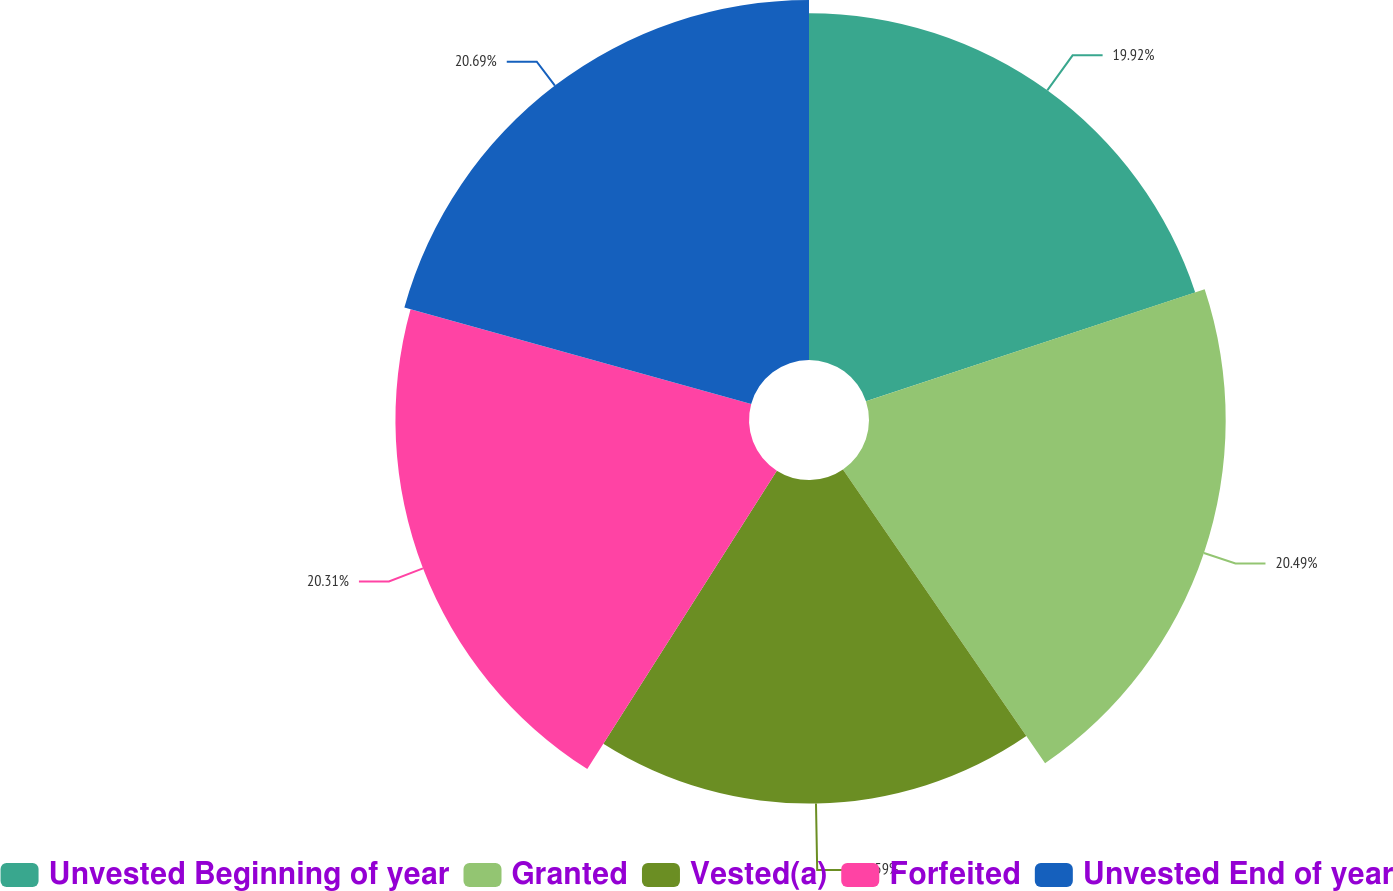<chart> <loc_0><loc_0><loc_500><loc_500><pie_chart><fcel>Unvested Beginning of year<fcel>Granted<fcel>Vested(a)<fcel>Forfeited<fcel>Unvested End of year<nl><fcel>19.92%<fcel>20.49%<fcel>18.59%<fcel>20.31%<fcel>20.68%<nl></chart> 